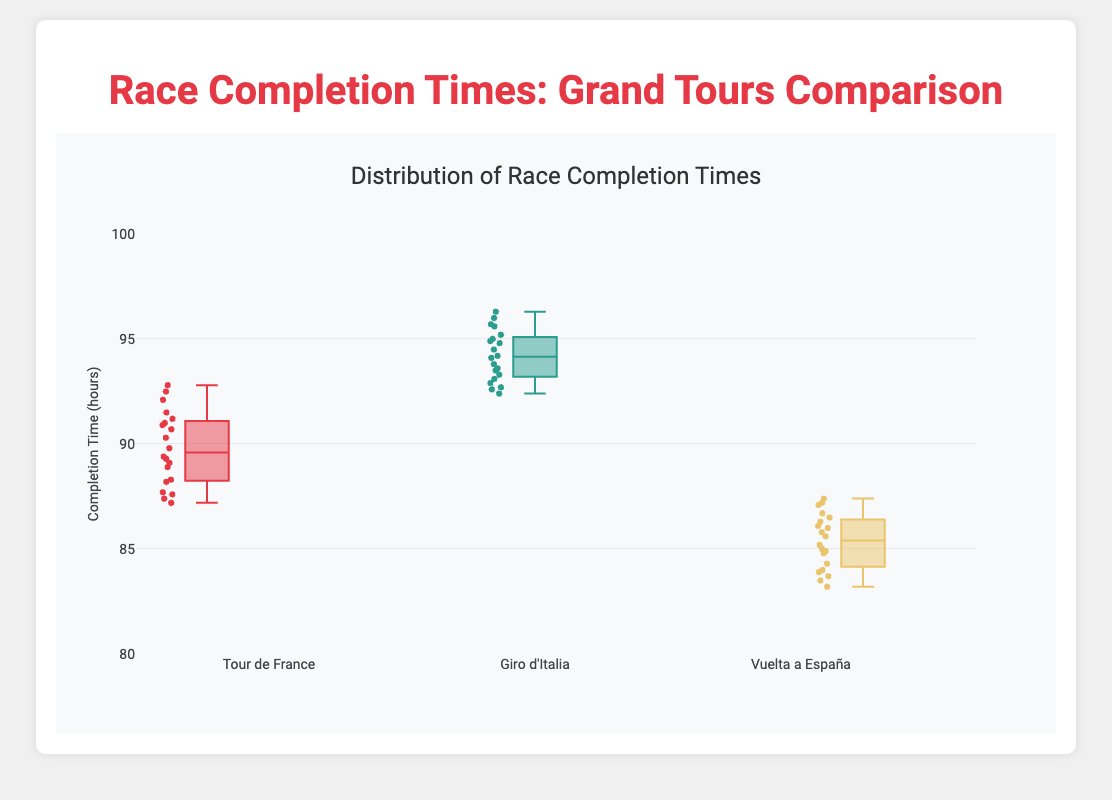Which race has the lowest median completion time? To find the race with the lowest median, look at the line that divides each box plot into two equal parts. The Vuelta a España box plot has the lowest median.
Answer: Vuelta a España What’s the range of completion times for the Giro d'Italia? The range is found by subtracting the minimum value from the maximum value. For the Giro d'Italia, the maximum is around 96.3, and the minimum is around 92.4, so 96.3 - 92.4.
Answer: 3.9 hours Which race has the most spread in completion times? The spread of the data can be identified by the length of the box. The Giro d'Italia box is the longest, indicating the greatest spread.
Answer: Giro d'Italia How do the outliers for Tour de France compare to its median completion time? Outliers are points outside the typical range of the data. For Tour de France, the highest outlier (around 92.8) is above the median (around 89.7).
Answer: Higher What is the interquartile range for Vuelta a España? The interquartile range (IQR) is the difference between the third quartile (Q3) and the first quartile (Q1). For Vuelta a España, this difference appears to be between approximately 86.7 and 84.0, so 86.7 - 84.0.
Answer: 2.7 Which race has the highest outlier? Outliers are plotted as individual points outside the main box. The highest outlier among the races is in Giro d'Italia, around 96.3.
Answer: Giro d'Italia Are there more completion times above or below the median in Tour de France? The median divides the data into two equal halves. For Tour de France, there are more data points above the median line than below it.
Answer: Above What’s the difference between the median completion times of Giro d'Italia and Vuelta a España? Subtract the median of Vuelta a España from the median of Giro d'Italia. The medians are approximately 94 and 85.7, respectively, so 94 - 85.7.
Answer: 8.3 hours Which race has the smallest interquartile range? The interquartile range is the width of the box. The smallest box appears in Vuelta a España.
Answer: Vuelta a España In which race do the completion times exhibit the least variability? Variability is indicated by the length of the box and the distance between data points. Vuelta a España has the smallest box and fewer outliers, indicating the least variability.
Answer: Vuelta a España 